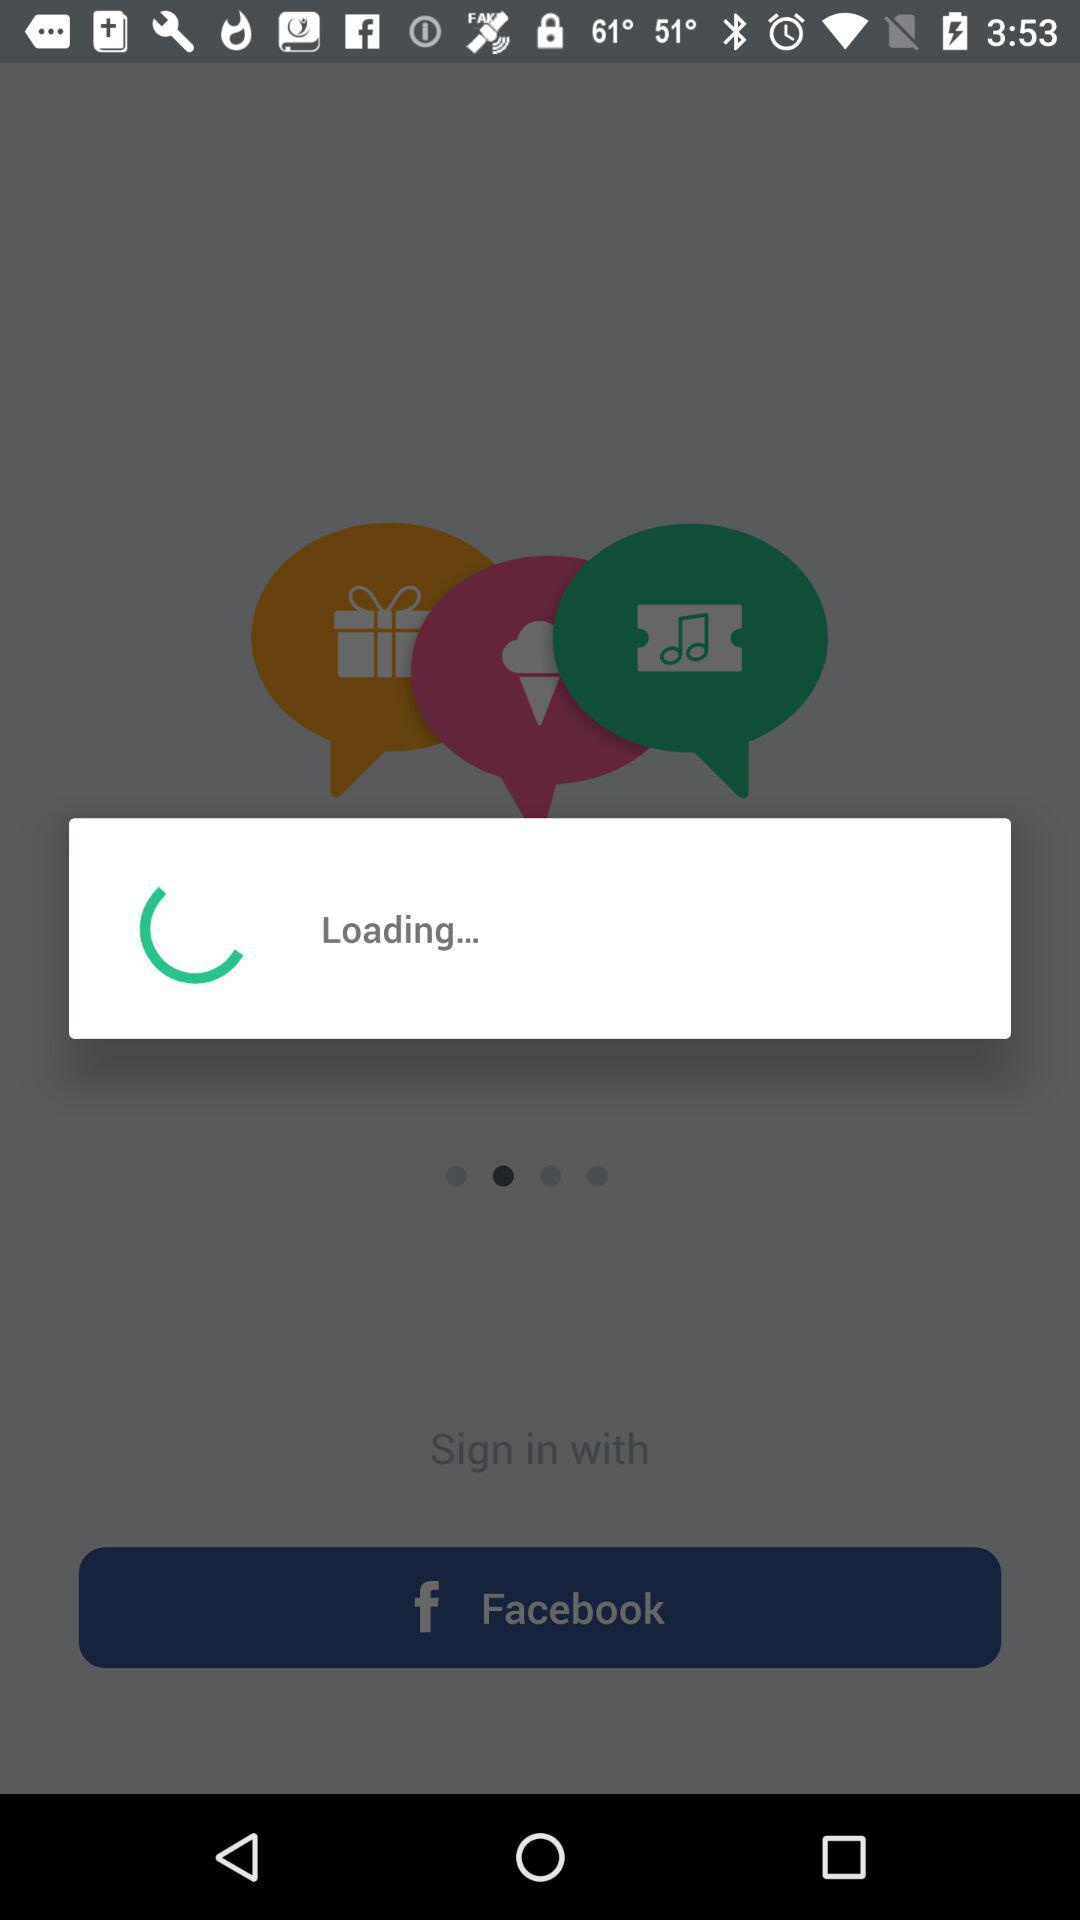What application can be used to log in? The application that can be used to log in is "Facebook". 